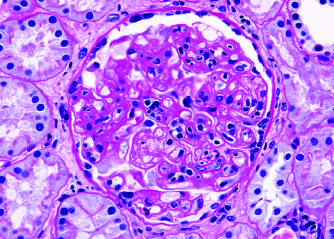does the glomerulus show inflammatory cells within the capillary loops glomerulitis, accumulation of mesangial matrix, and duplication of the capillary basement membrane?
Answer the question using a single word or phrase. Yes 